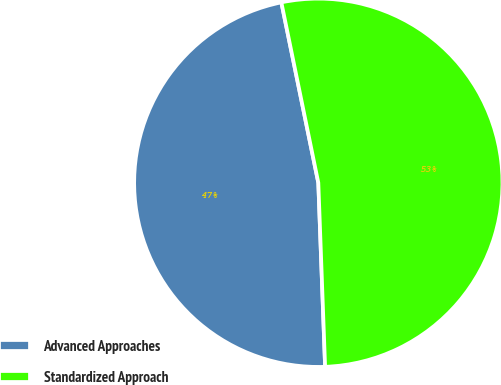Convert chart. <chart><loc_0><loc_0><loc_500><loc_500><pie_chart><fcel>Advanced Approaches<fcel>Standardized Approach<nl><fcel>47.37%<fcel>52.63%<nl></chart> 